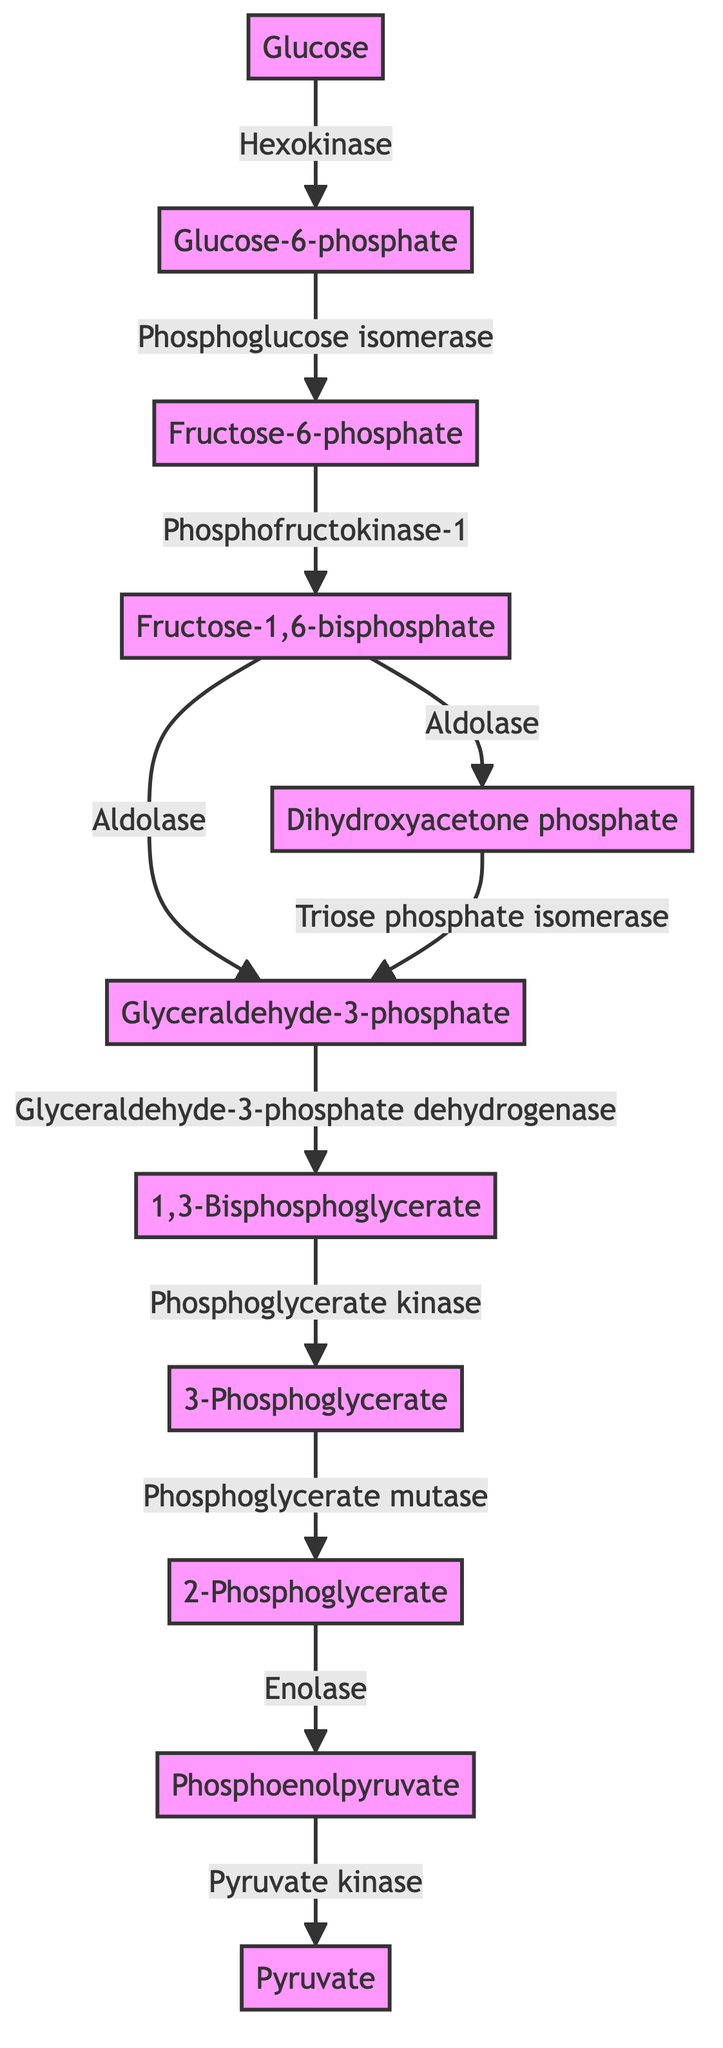What is the initial substrate in glycolysis? The diagram shows "Glucose" as the first node, indicating that it is the starting point of the glycolysis pathway.
Answer: Glucose Which enzyme converts Glucose to Glucose-6-phosphate? According to the diagram, the directed edge from "Glucose" to "Glucose-6-phosphate" is labeled "Hexokinase," which identifies the enzyme responsible for this conversion.
Answer: Hexokinase How many products are formed from Fructose-1,6-bisphosphate? The diagram depicts directed edges from "Fructose-1,6-bisphosphate" to "Glyceraldehyde-3-phosphate" and "Dihydroxyacetone phosphate," indicating that two products are formed from it.
Answer: 2 What is the final product of glycolysis? The last node in the diagram is labeled "Pyruvate," showing that it is the final product of the glycolytic pathway.
Answer: Pyruvate Which step follows the conversion of 2-Phosphoglycerate? The edge directed from "2-Phosphoglycerate" to "Phosphoenolpyruvate" shows that this step is the next in the glycolysis sequence, indicating the conversion taking place here.
Answer: Phosphoenolpyruvate What two compounds are produced from Fructose-1,6-bisphosphate? The diagram indicates two branches from "Fructose-1,6-bisphosphate," leading to "Glyceraldehyde-3-phosphate" and "Dihydroxyacetone phosphate," which are the two produced compounds.
Answer: Glyceraldehyde-3-phosphate and Dihydroxyacetone phosphate Which enzyme is responsible for the last step of glycolysis? The directed edge from "Phosphoenolpyruvate" to "Pyruvate" is labeled "Pyruvate kinase," indicating that this enzyme drives the final reaction in the glycolytic pathway.
Answer: Pyruvate kinase What is the total number of enzymes represented in the diagram? By counting the labeled edges (the enzymes) between nodes, there are a total of ten distinct enzymes connecting the various compounds in glycolysis.
Answer: 10 What is the relationship between Dihydroxyacetone phosphate and Glyceraldehyde-3-phosphate? The edge from "Dihydroxyacetone phosphate" to "Glyceraldehyde-3-phosphate," labeled "Triose phosphate isomerase," indicates that this enzyme interconverts the two compounds, establishing a direct relationship.
Answer: Interconversion via Triose phosphate isomerase 